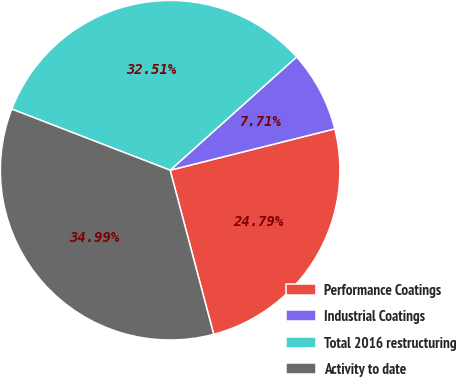Convert chart to OTSL. <chart><loc_0><loc_0><loc_500><loc_500><pie_chart><fcel>Performance Coatings<fcel>Industrial Coatings<fcel>Total 2016 restructuring<fcel>Activity to date<nl><fcel>24.79%<fcel>7.71%<fcel>32.51%<fcel>34.99%<nl></chart> 